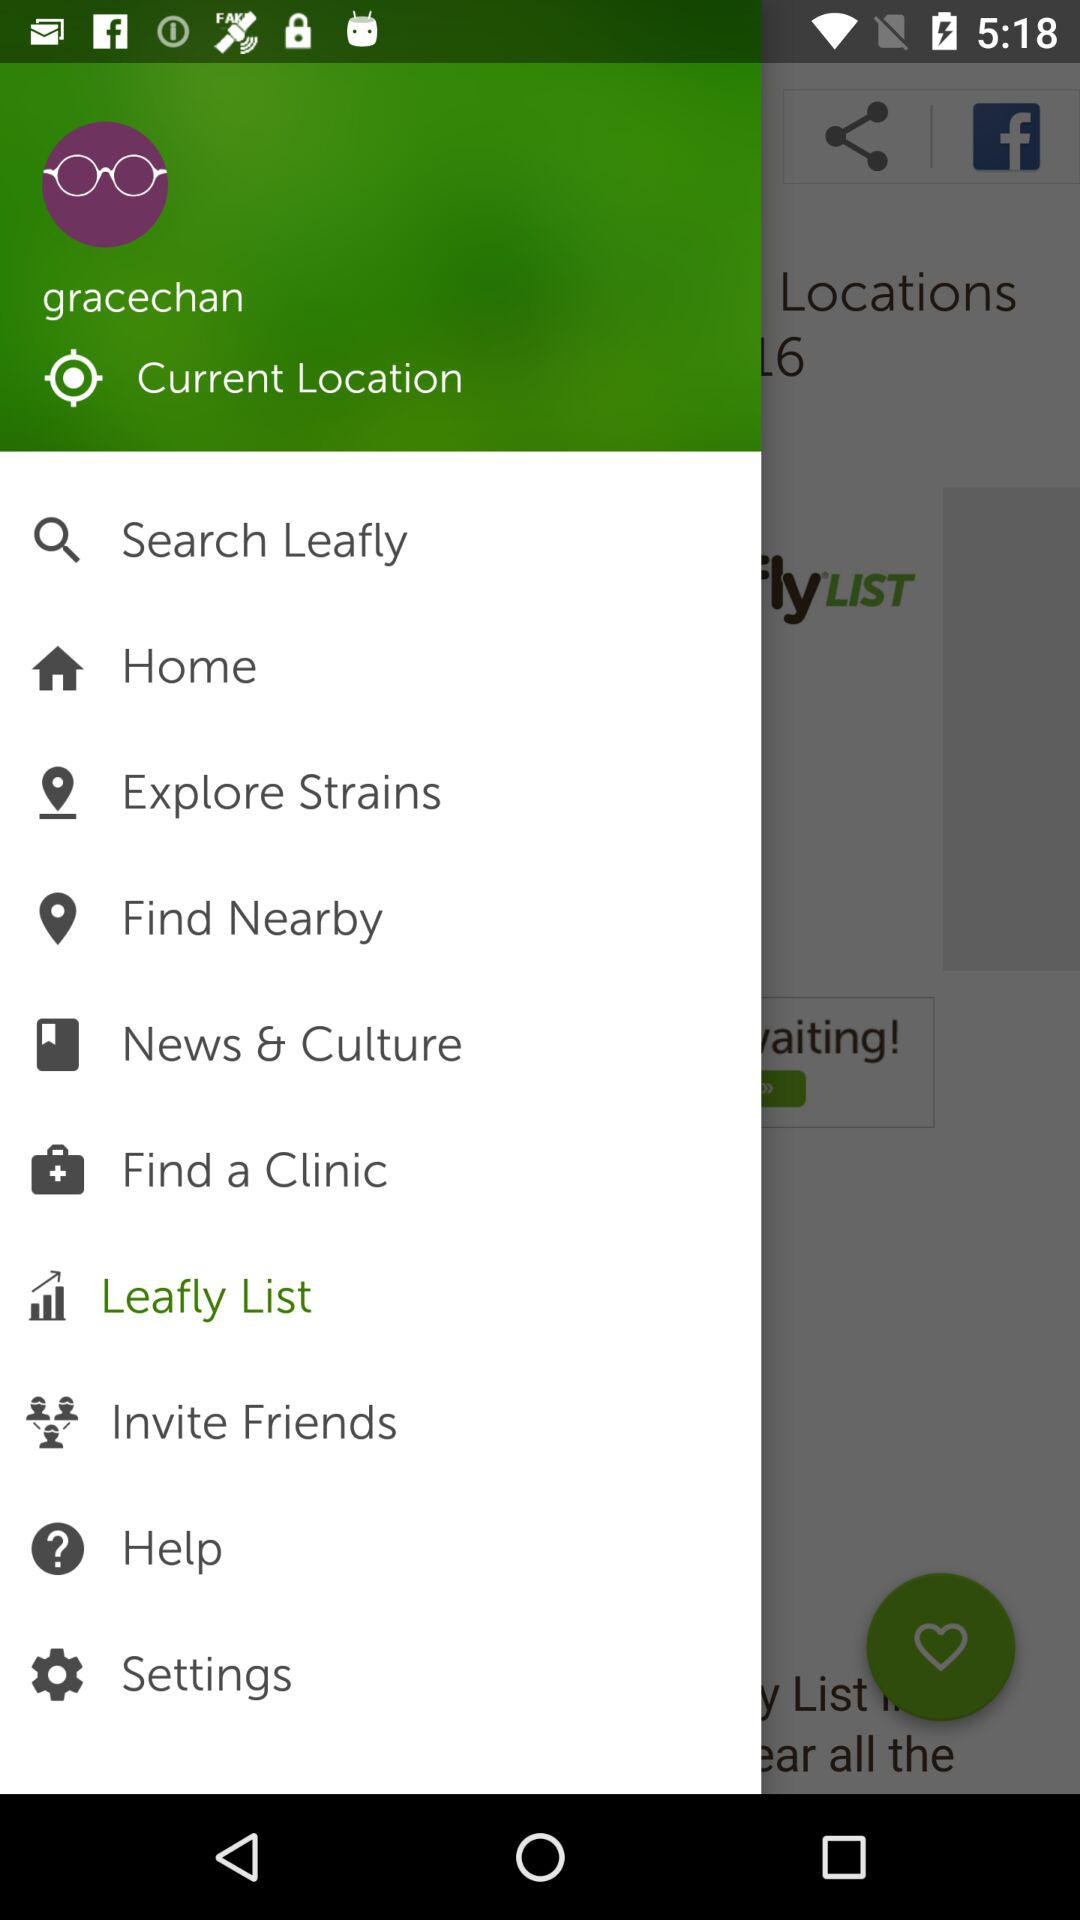What is the selected option? The selected option is Leafly List. 